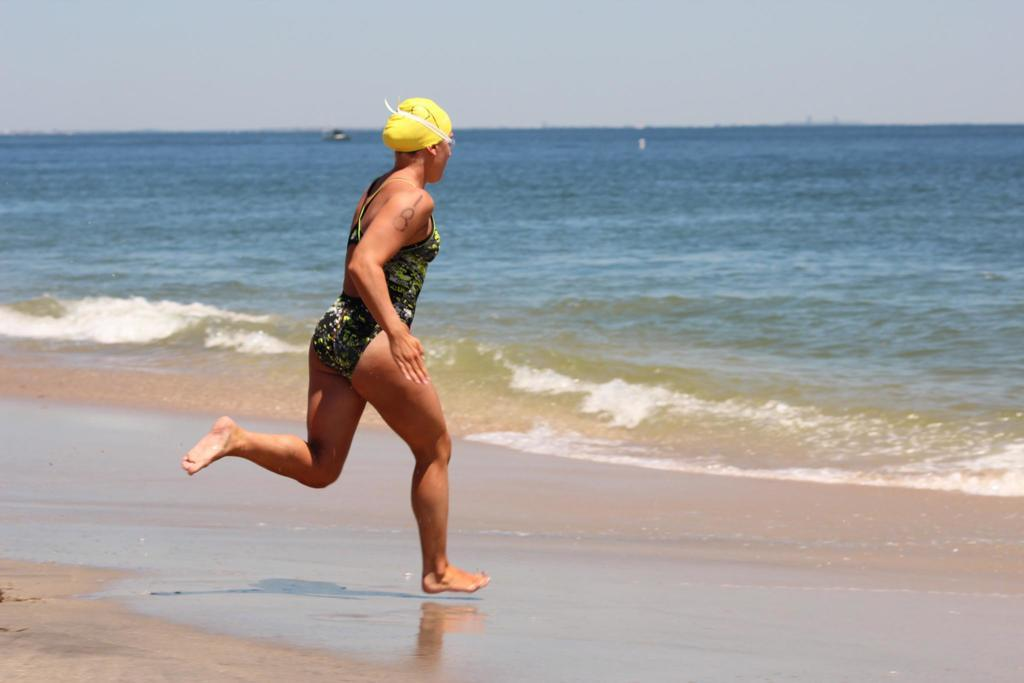What is the main subject in the foreground of the picture? There is a woman in the foreground of the picture. What is the woman doing in the image? The woman is running on the beach. What can be seen in the center of the picture? There is a water body in the center of the picture. What is visible in the background of the image? The background of the image is the sky. What type of drum can be seen in the woman's hand in the image? There is no drum present in the image; the woman is running on the beach. Can you tell me where the office is located in the image? There is no office present in the image; it features a woman running on the beach with a water body and the sky in the background. 